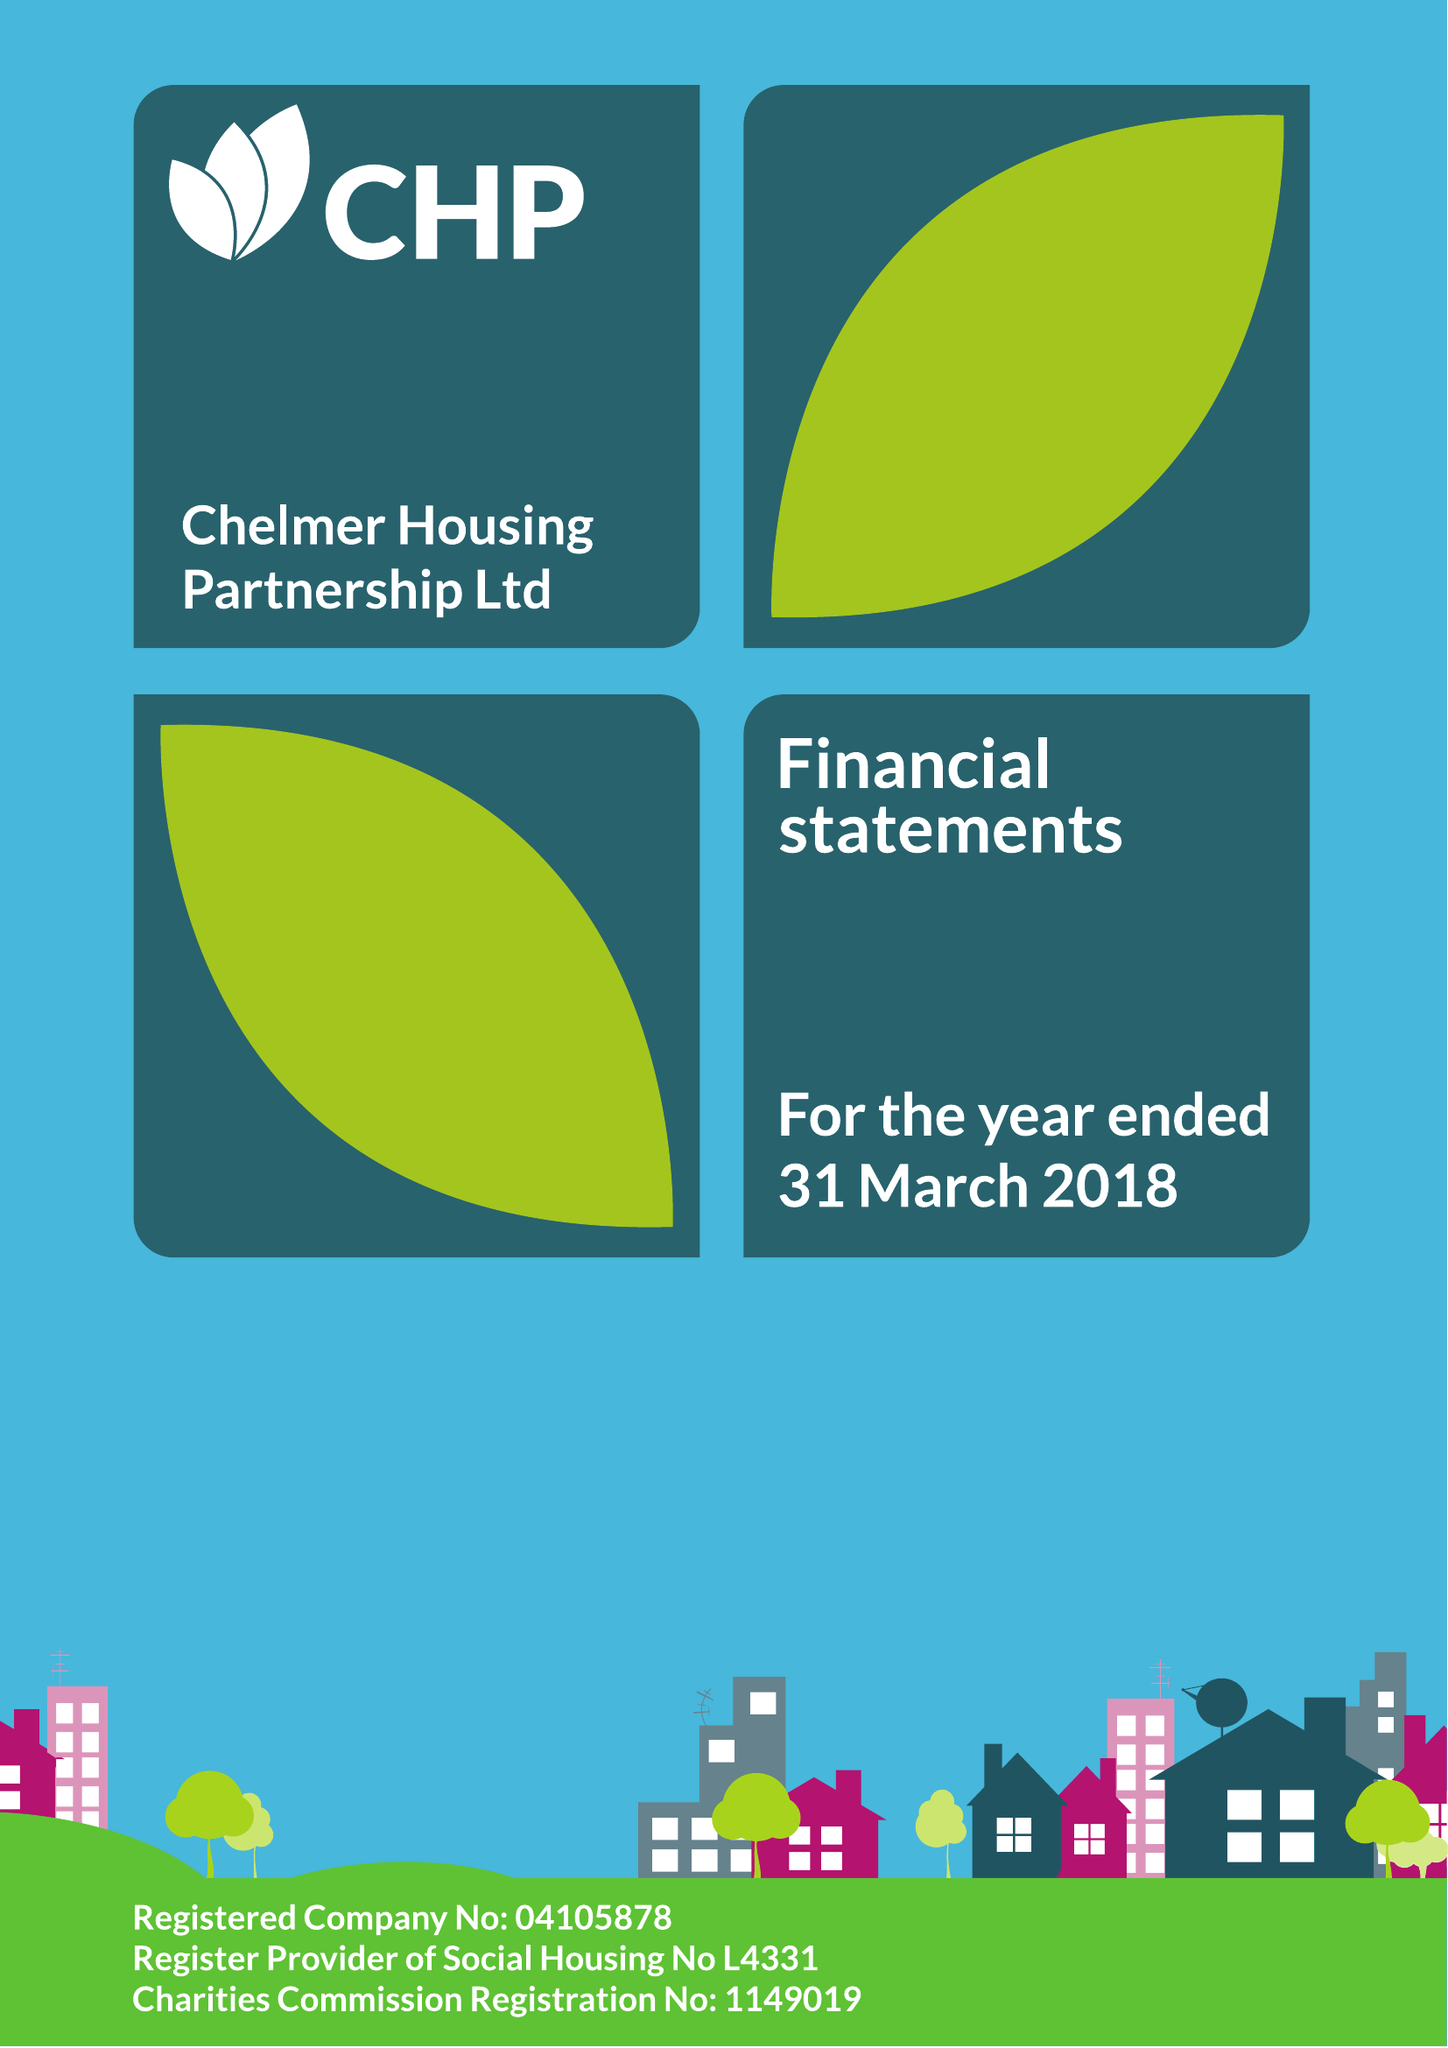What is the value for the income_annually_in_british_pounds?
Answer the question using a single word or phrase. 77184000.00 